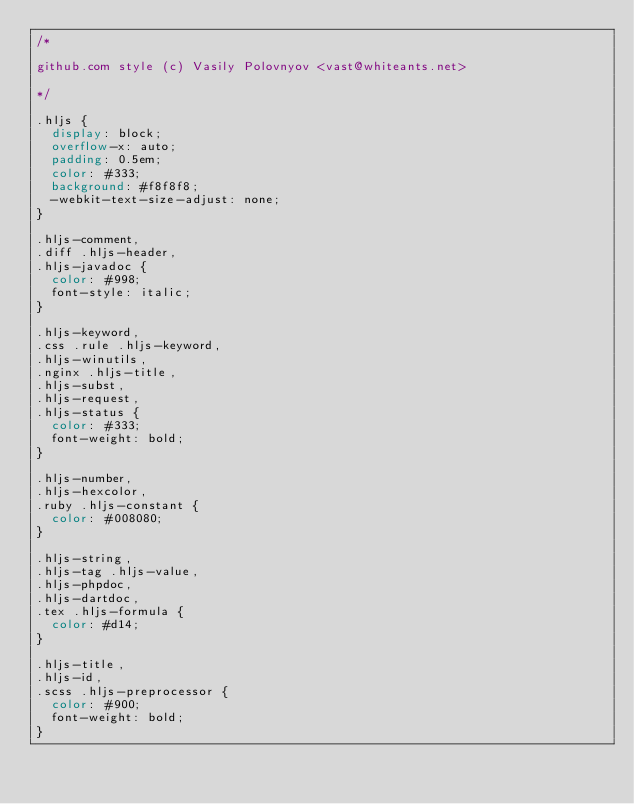Convert code to text. <code><loc_0><loc_0><loc_500><loc_500><_CSS_>/*

github.com style (c) Vasily Polovnyov <vast@whiteants.net>

*/

.hljs {
  display: block;
  overflow-x: auto;
  padding: 0.5em;
  color: #333;
  background: #f8f8f8;
  -webkit-text-size-adjust: none;
}

.hljs-comment,
.diff .hljs-header,
.hljs-javadoc {
  color: #998;
  font-style: italic;
}

.hljs-keyword,
.css .rule .hljs-keyword,
.hljs-winutils,
.nginx .hljs-title,
.hljs-subst,
.hljs-request,
.hljs-status {
  color: #333;
  font-weight: bold;
}

.hljs-number,
.hljs-hexcolor,
.ruby .hljs-constant {
  color: #008080;
}

.hljs-string,
.hljs-tag .hljs-value,
.hljs-phpdoc,
.hljs-dartdoc,
.tex .hljs-formula {
  color: #d14;
}

.hljs-title,
.hljs-id,
.scss .hljs-preprocessor {
  color: #900;
  font-weight: bold;
}
</code> 